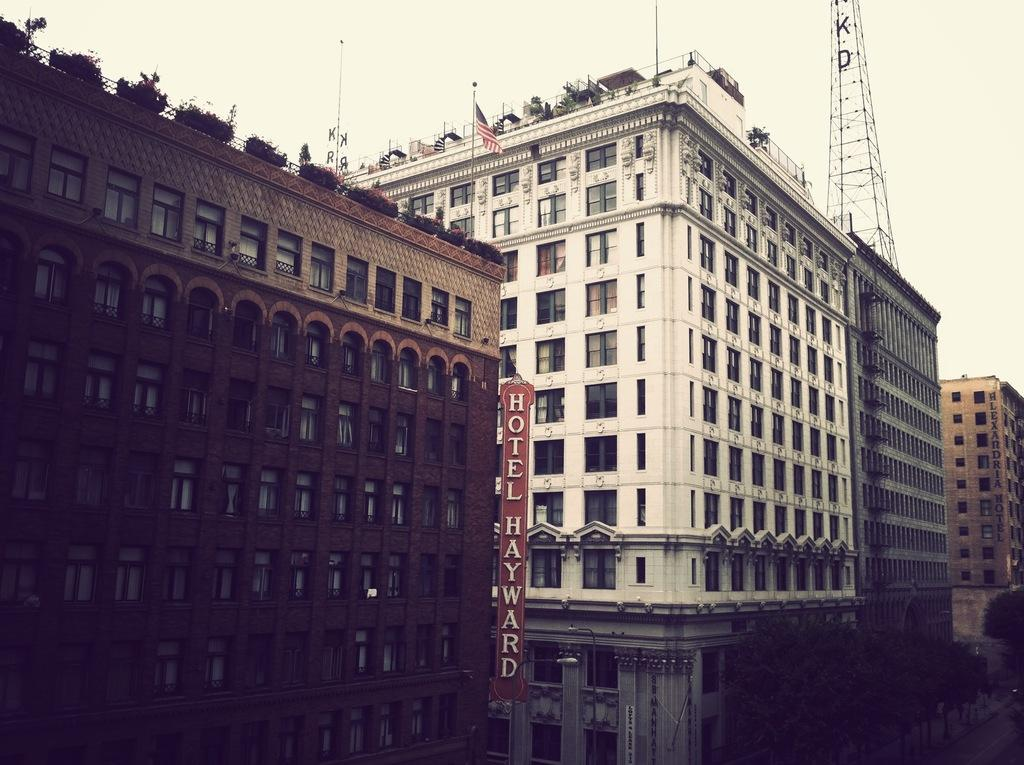What type of structures can be seen in the image? There are buildings in the image. What else can be seen in the image besides the buildings? There are poles, a flag, windows, and writing visible in the image. Can you describe the flag in the image? The flag is one of the items visible in the image. What might the writing be used for in the image? The writing could be used for identification, information, or decoration. Can you tell me how many bags of popcorn are visible in the image? There are no bags of popcorn present in the image. What type of discovery was made at the location depicted in the image? There is no indication of a discovery in the image; it simply shows buildings, poles, a flag, windows, and writing. 